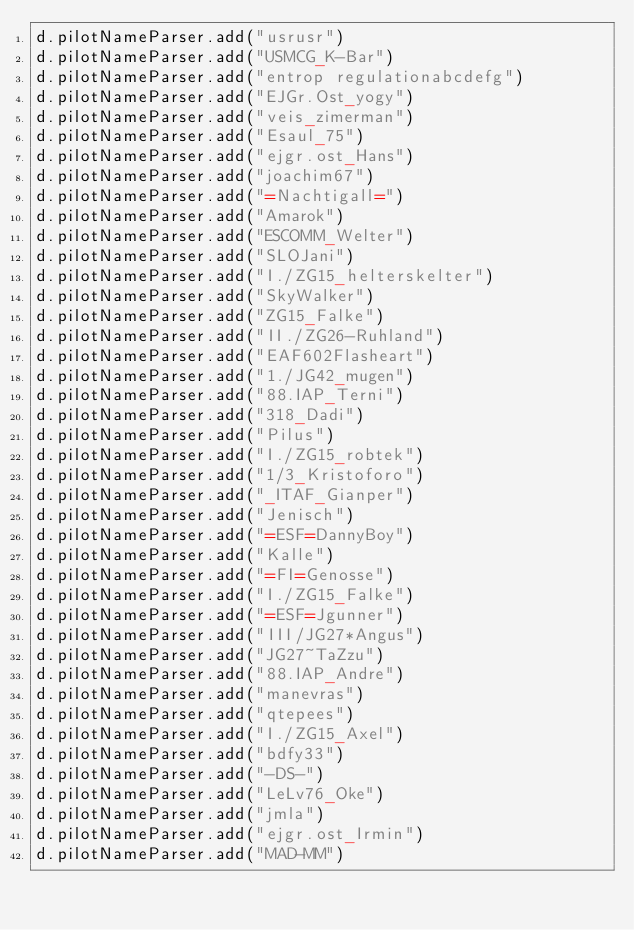<code> <loc_0><loc_0><loc_500><loc_500><_Scala_>d.pilotNameParser.add("usrusr")
d.pilotNameParser.add("USMCG_K-Bar")
d.pilotNameParser.add("entrop regulationabcdefg")
d.pilotNameParser.add("EJGr.Ost_yogy")
d.pilotNameParser.add("veis_zimerman")
d.pilotNameParser.add("Esaul_75")
d.pilotNameParser.add("ejgr.ost_Hans")
d.pilotNameParser.add("joachim67")
d.pilotNameParser.add("=Nachtigall=")
d.pilotNameParser.add("Amarok")
d.pilotNameParser.add("ESCOMM_Welter")
d.pilotNameParser.add("SLOJani")
d.pilotNameParser.add("I./ZG15_helterskelter")
d.pilotNameParser.add("SkyWalker")
d.pilotNameParser.add("ZG15_Falke")
d.pilotNameParser.add("II./ZG26-Ruhland")
d.pilotNameParser.add("EAF602Flasheart")
d.pilotNameParser.add("1./JG42_mugen")
d.pilotNameParser.add("88.IAP_Terni")
d.pilotNameParser.add("318_Dadi")
d.pilotNameParser.add("Pilus")
d.pilotNameParser.add("I./ZG15_robtek")
d.pilotNameParser.add("1/3_Kristoforo")
d.pilotNameParser.add("_ITAF_Gianper")
d.pilotNameParser.add("Jenisch")
d.pilotNameParser.add("=ESF=DannyBoy")
d.pilotNameParser.add("Kalle")
d.pilotNameParser.add("=FI=Genosse")
d.pilotNameParser.add("I./ZG15_Falke")
d.pilotNameParser.add("=ESF=Jgunner")
d.pilotNameParser.add("III/JG27*Angus")
d.pilotNameParser.add("JG27~TaZzu")
d.pilotNameParser.add("88.IAP_Andre")
d.pilotNameParser.add("manevras")
d.pilotNameParser.add("qtepees")
d.pilotNameParser.add("I./ZG15_Axel")
d.pilotNameParser.add("bdfy33")
d.pilotNameParser.add("-DS-")
d.pilotNameParser.add("LeLv76_Oke")
d.pilotNameParser.add("jmla")
d.pilotNameParser.add("ejgr.ost_Irmin")
d.pilotNameParser.add("MAD-MM")</code> 